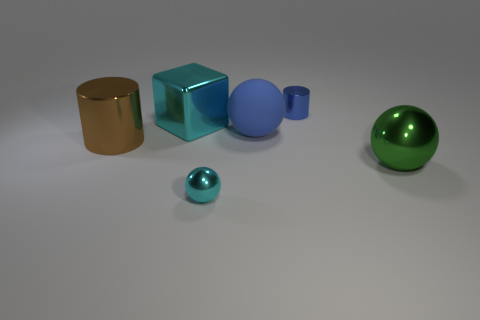There is a blue object that is the same shape as the small cyan shiny object; what is its material?
Your response must be concise. Rubber. What is the material of the cyan object that is the same size as the green sphere?
Offer a terse response. Metal. Does the large thing that is to the right of the small blue object have the same material as the big cylinder?
Keep it short and to the point. Yes. What shape is the rubber object that is the same size as the brown shiny object?
Offer a very short reply. Sphere. What number of balls have the same color as the small metallic cylinder?
Keep it short and to the point. 1. Are there fewer brown metal cylinders in front of the large brown cylinder than metallic things that are behind the big block?
Your response must be concise. Yes. Are there any cylinders behind the large brown cylinder?
Give a very brief answer. Yes. Is there a small blue cylinder to the right of the tiny object that is behind the tiny shiny object that is in front of the green metallic sphere?
Give a very brief answer. No. Is the shape of the green metal thing that is right of the brown object the same as  the matte thing?
Provide a short and direct response. Yes. What color is the small cylinder that is made of the same material as the large green sphere?
Provide a succinct answer. Blue. 